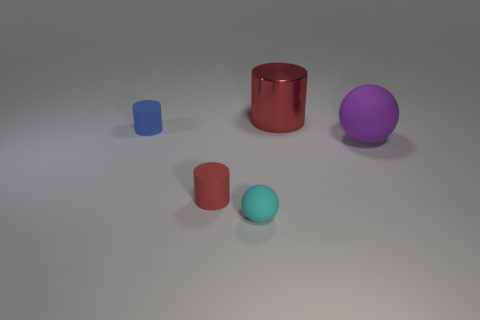What is the color of the small ball that is made of the same material as the big purple object?
Provide a short and direct response. Cyan. Is the number of big green cylinders greater than the number of red objects?
Provide a succinct answer. No. How many things are either things on the left side of the tiny red rubber object or tiny blue rubber cylinders?
Make the answer very short. 1. Is there a red thing of the same size as the cyan object?
Your response must be concise. Yes. Is the number of green cubes less than the number of blue cylinders?
Provide a short and direct response. Yes. How many spheres are either tiny red objects or small objects?
Make the answer very short. 1. How many small matte objects have the same color as the big metallic cylinder?
Your response must be concise. 1. There is a cylinder that is both behind the small red thing and left of the tiny cyan sphere; what is its size?
Give a very brief answer. Small. Are there fewer small blue rubber cylinders in front of the metal object than small matte spheres?
Make the answer very short. No. Is the small red cylinder made of the same material as the purple object?
Ensure brevity in your answer.  Yes. 